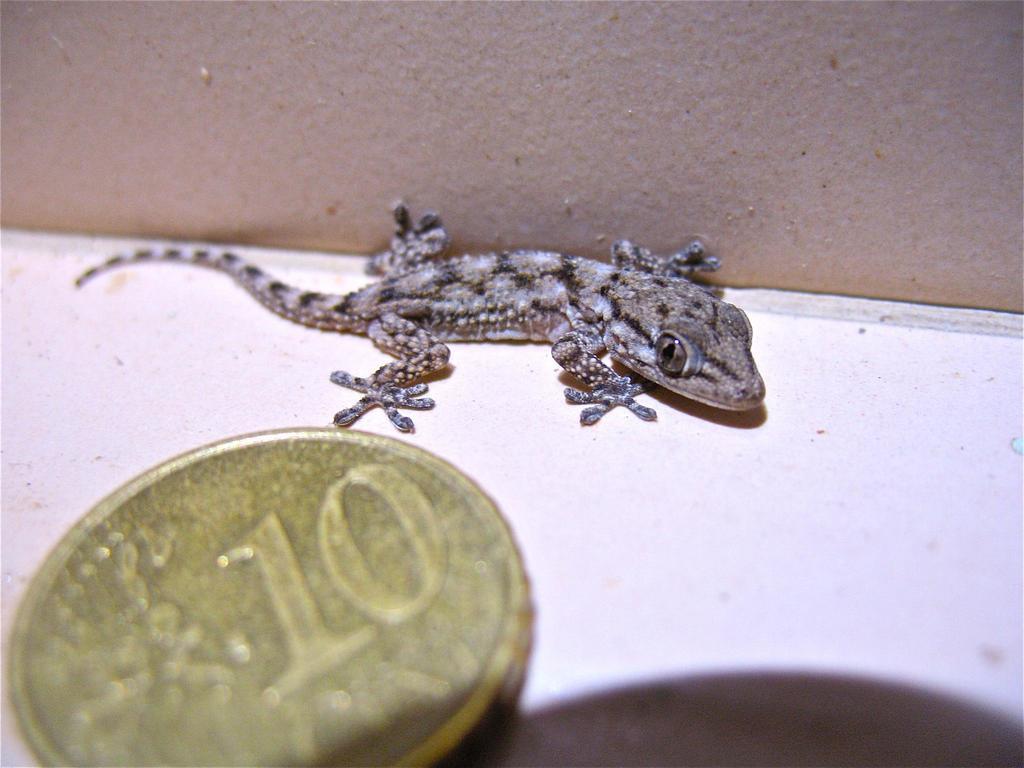Describe this image in one or two sentences. In the picture we can see a lizard on the white color surface and near it, we can see a coin representing a number ten on it. 